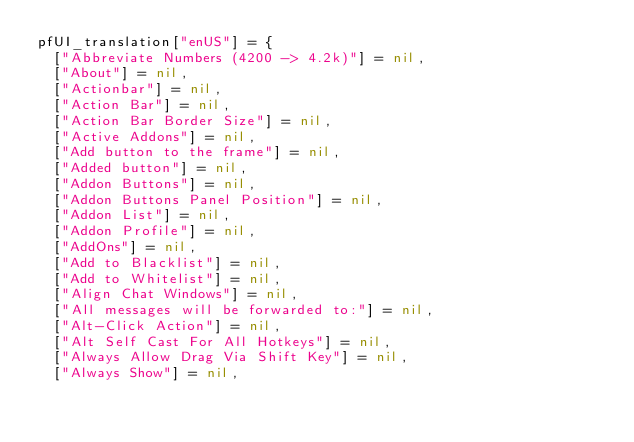<code> <loc_0><loc_0><loc_500><loc_500><_Lua_>pfUI_translation["enUS"] = {
  ["Abbreviate Numbers (4200 -> 4.2k)"] = nil,
  ["About"] = nil,
  ["Actionbar"] = nil,
  ["Action Bar"] = nil,
  ["Action Bar Border Size"] = nil,
  ["Active Addons"] = nil,
  ["Add button to the frame"] = nil,
  ["Added button"] = nil,
  ["Addon Buttons"] = nil,
  ["Addon Buttons Panel Position"] = nil,
  ["Addon List"] = nil,
  ["Addon Profile"] = nil,
  ["AddOns"] = nil,
  ["Add to Blacklist"] = nil,
  ["Add to Whitelist"] = nil,
  ["Align Chat Windows"] = nil,
  ["All messages will be forwarded to:"] = nil,
  ["Alt-Click Action"] = nil,
  ["Alt Self Cast For All Hotkeys"] = nil,
  ["Always Allow Drag Via Shift Key"] = nil,
  ["Always Show"] = nil,</code> 